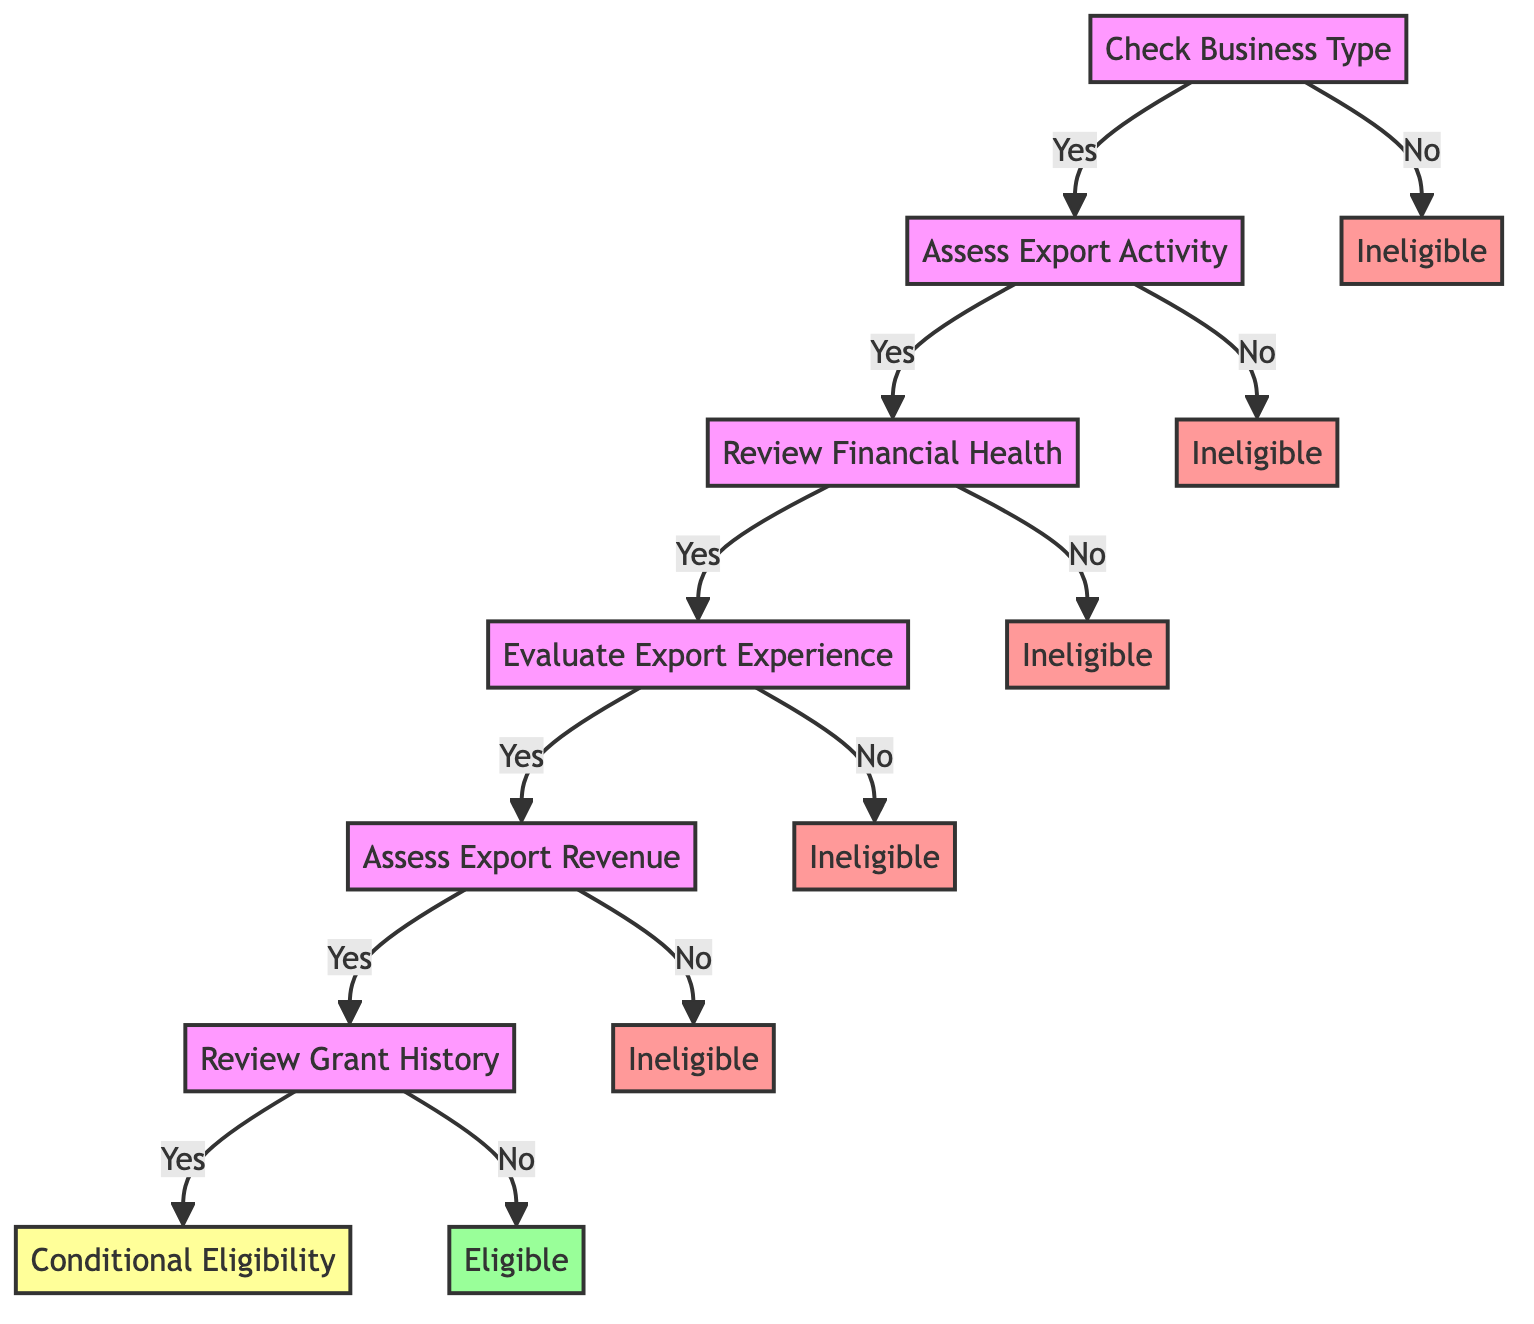What is the first step in the eligibility criteria? The first step is to check if the applicant is a registered business entity. This is the initial question posed in the diagram from which the flow begins.
Answer: Check Business Type How many total steps are there in the decision tree? The decision tree consists of six main steps that are sequentially evaluated to determine eligibility. Each step focuses on a different aspect of eligibility related to export grants.
Answer: Six What happens if the answer to "Is the business financially solvent?" is no? If the answer is no to the financial health check, the business is deemed ineligible right away, with no further steps proceeding from that point.
Answer: Ineligible What is the outcome if the business derives more than 10% of its revenue from exports? If the business derives more than 10% of its revenue from exports, it proceeds to the next step, which is to review the history of grants received.
Answer: Review Grant History How many times can the business be categorized as "Ineligible"? The business can be categorized as "Ineligible" five times throughout the process, depending on the answers it provides to several key eligibility questions.
Answer: Five What result does a business receive if it has received export grants in the past two years? If a business has received export grants in the past two years, it is categorized as "Conditional Eligibility," indicating a specific condition it must meet to be fully eligible.
Answer: Conditional Eligibility What is the outcome for a business that is a registered entity, exports goods, is financially solvent, has been exporting for more than a year, derives more than 10% of revenue from exports, and has not received any grants in the past two years? In this scenario, the business meets all eligibility requirements and is classified as "Eligible," allowing it access to export grants without any other conditions.
Answer: Eligible In which step do we evaluate the export experience of the business? The evaluation of the export experience occurs in step four of the decision tree where the question about exporting for more than one year is asked.
Answer: Evaluate Export Experience What is the consequence of answering "No" to the question about the business engaging in exporting goods or services? Answering "No" indicates that the business does not engage in export activities, resulting in it being deemed ineligible and ending the assessment process there.
Answer: Ineligible 